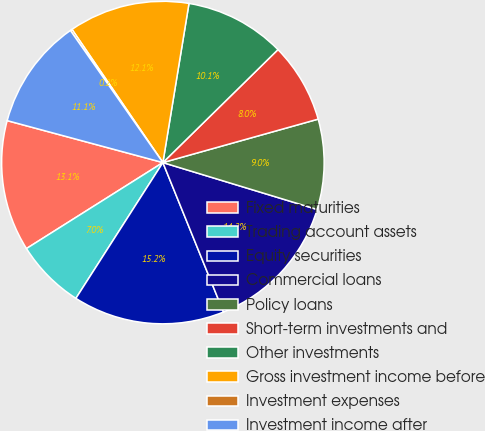Convert chart. <chart><loc_0><loc_0><loc_500><loc_500><pie_chart><fcel>Fixed maturities<fcel>Trading account assets<fcel>Equity securities<fcel>Commercial loans<fcel>Policy loans<fcel>Short-term investments and<fcel>Other investments<fcel>Gross investment income before<fcel>Investment expenses<fcel>Investment income after<nl><fcel>13.14%<fcel>6.98%<fcel>15.2%<fcel>14.17%<fcel>9.04%<fcel>8.01%<fcel>10.06%<fcel>12.12%<fcel>0.19%<fcel>11.09%<nl></chart> 